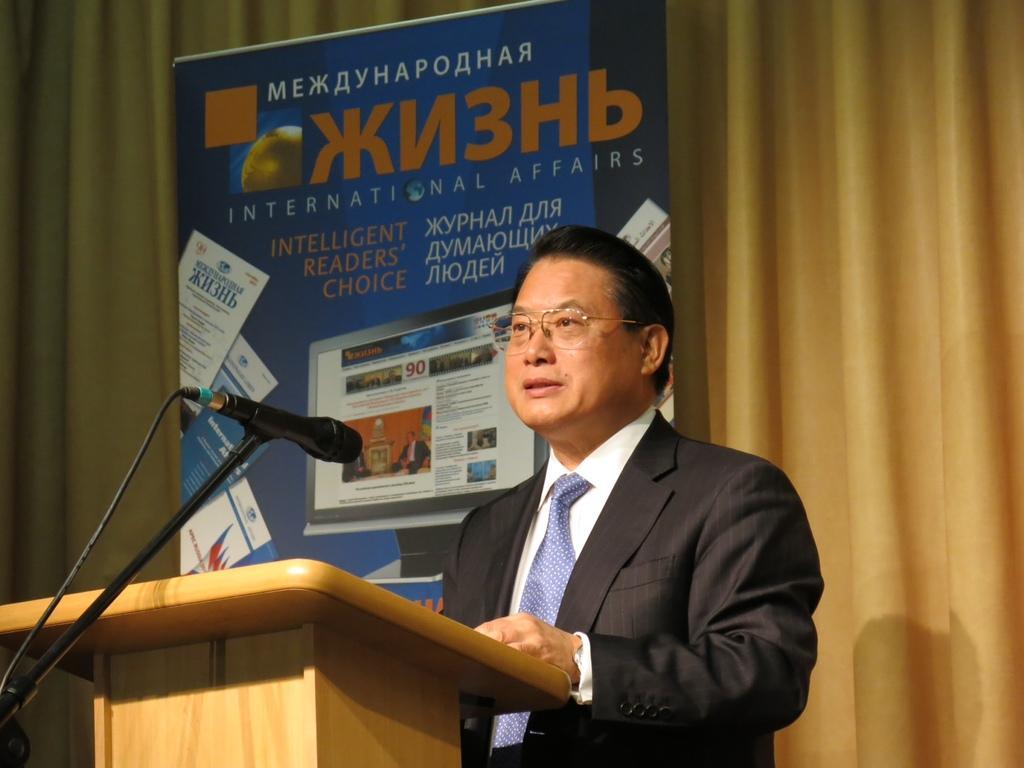Describe this image in one or two sentences. Here I can see a man wearing a suit and standing in front of the podium facing towards the left side. On the left side there is a mike stand. At the back of him there is a banner on which I can see some text and an image of a monitor. Behind the banner there is a curtain. 